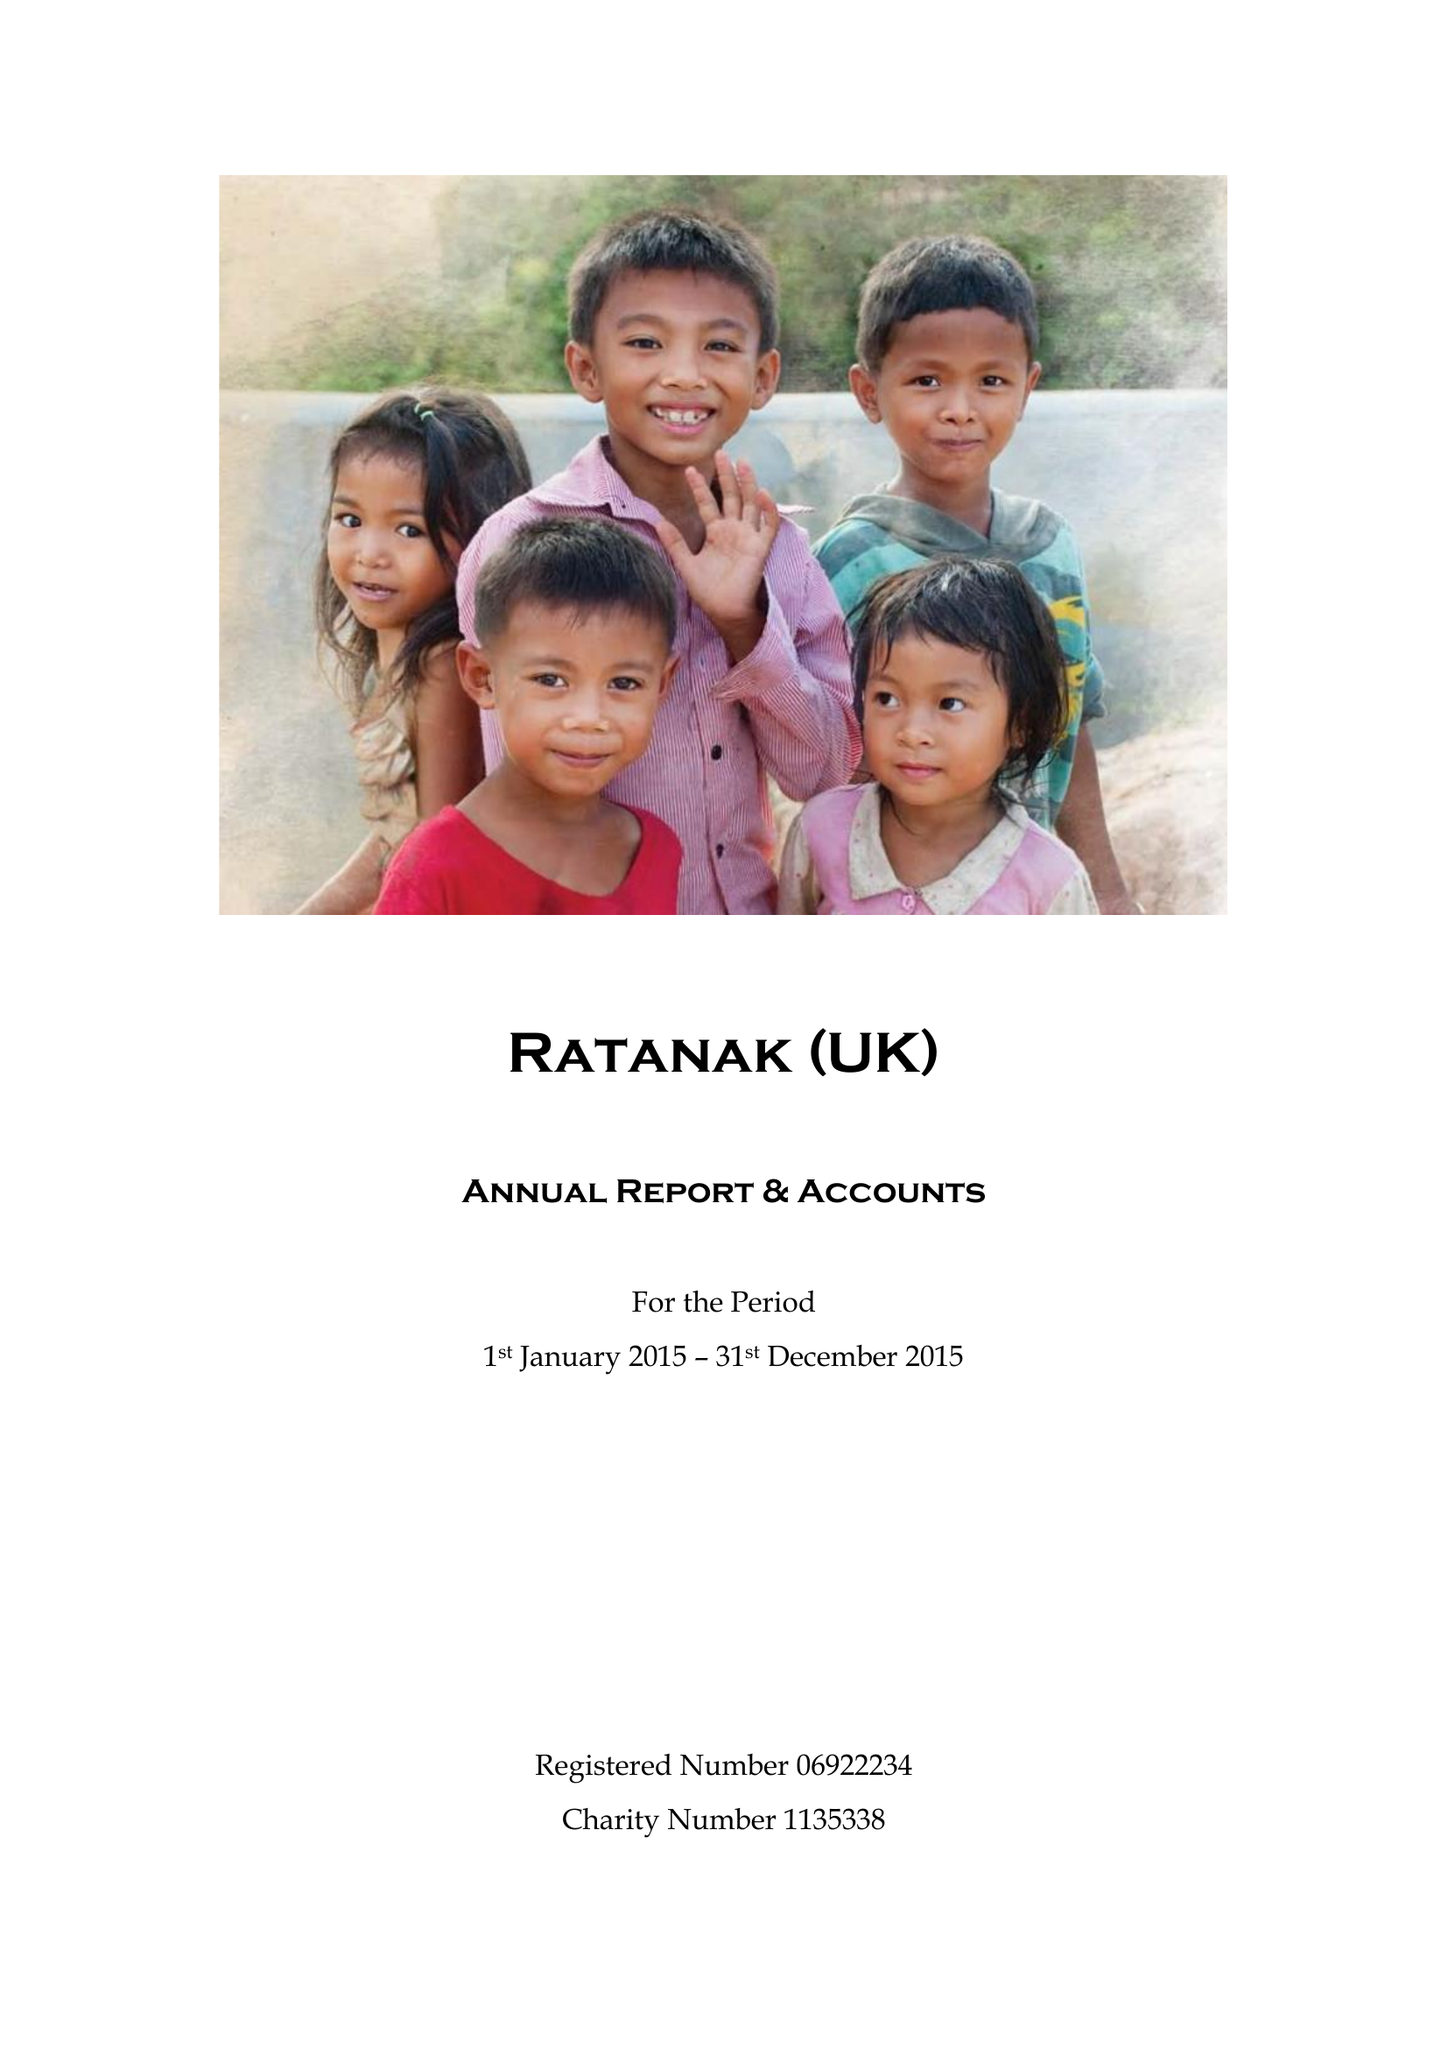What is the value for the address__postcode?
Answer the question using a single word or phrase. DL7 9TD 